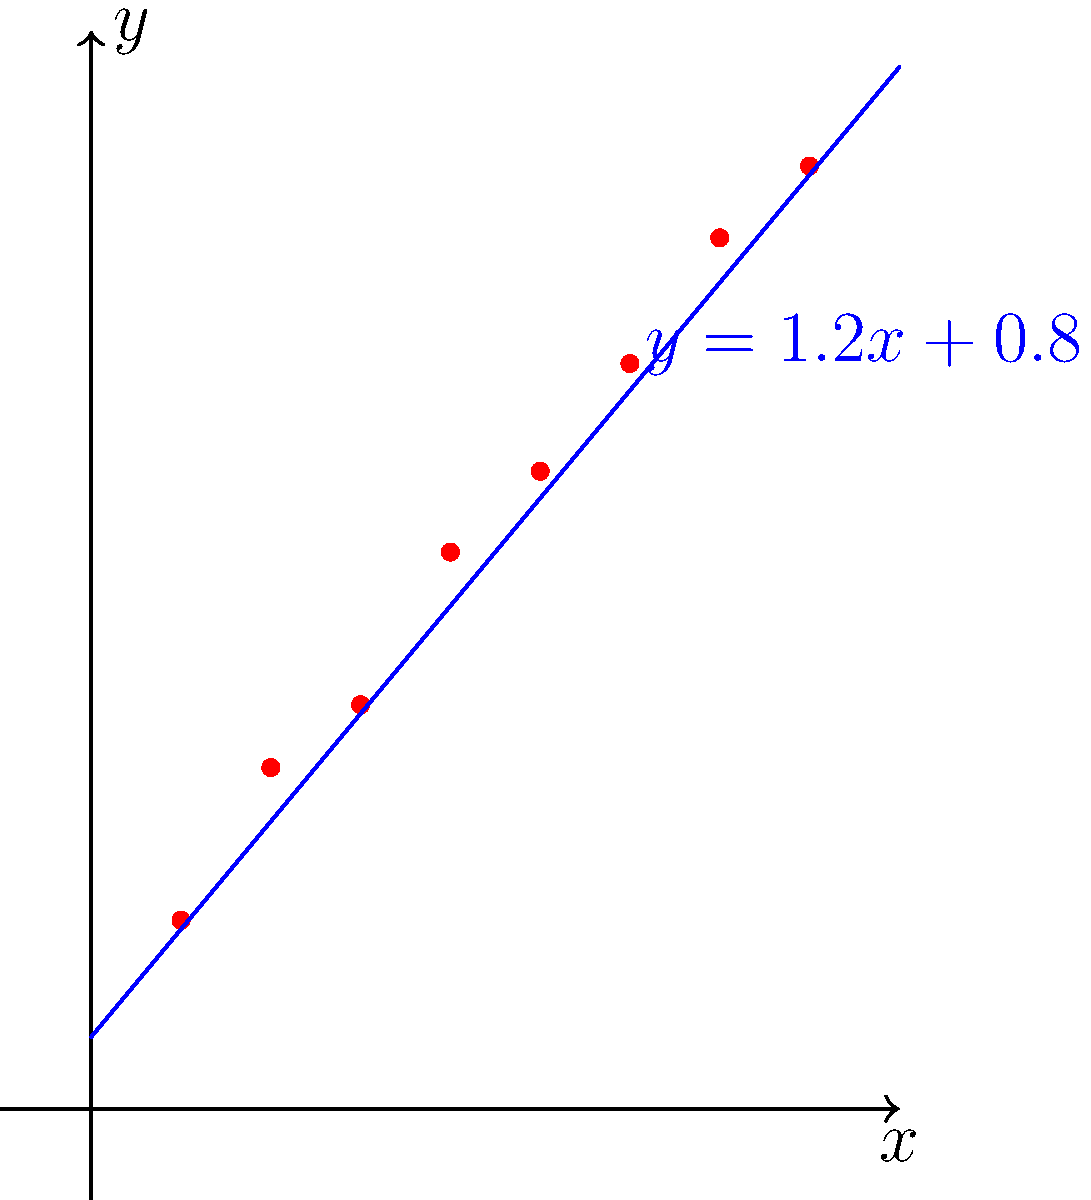Given the scattered data points in the coordinate system and the fitted regression line $y = 1.2x + 0.8$, calculate the coefficient of determination ($R^2$) to assess the goodness of fit. Assume the following sums have been calculated:

$\sum_{i=1}^{8} (y_i - \bar{y})^2 = 72.5$
$\sum_{i=1}^{8} (\hat{y}_i - \bar{y})^2 = 68.8$

Where $y_i$ are the observed values, $\hat{y}_i$ are the predicted values from the regression line, and $\bar{y}$ is the mean of the observed values. To calculate the coefficient of determination ($R^2$), we'll follow these steps:

1) The coefficient of determination is defined as:

   $R^2 = \frac{SSR}{SST} = 1 - \frac{SSE}{SST}$

   Where:
   SSR = Sum of Squares due to Regression
   SST = Total Sum of Squares
   SSE = Sum of Squared Errors

2) We're given:
   SST = $\sum_{i=1}^{8} (y_i - \bar{y})^2 = 72.5$
   SSR = $\sum_{i=1}^{8} (\hat{y}_i - \bar{y})^2 = 68.8$

3) We can calculate SSE:
   SSE = SST - SSR = 72.5 - 68.8 = 3.7

4) Now we can calculate $R^2$:
   $R^2 = \frac{SSR}{SST} = \frac{68.8}{72.5} = 0.9490$

5) We can verify this using the alternative formula:
   $R^2 = 1 - \frac{SSE}{SST} = 1 - \frac{3.7}{72.5} = 0.9490$

Therefore, the coefficient of determination ($R^2$) is approximately 0.9490 or 94.90%.
Answer: $R^2 \approx 0.9490$ 